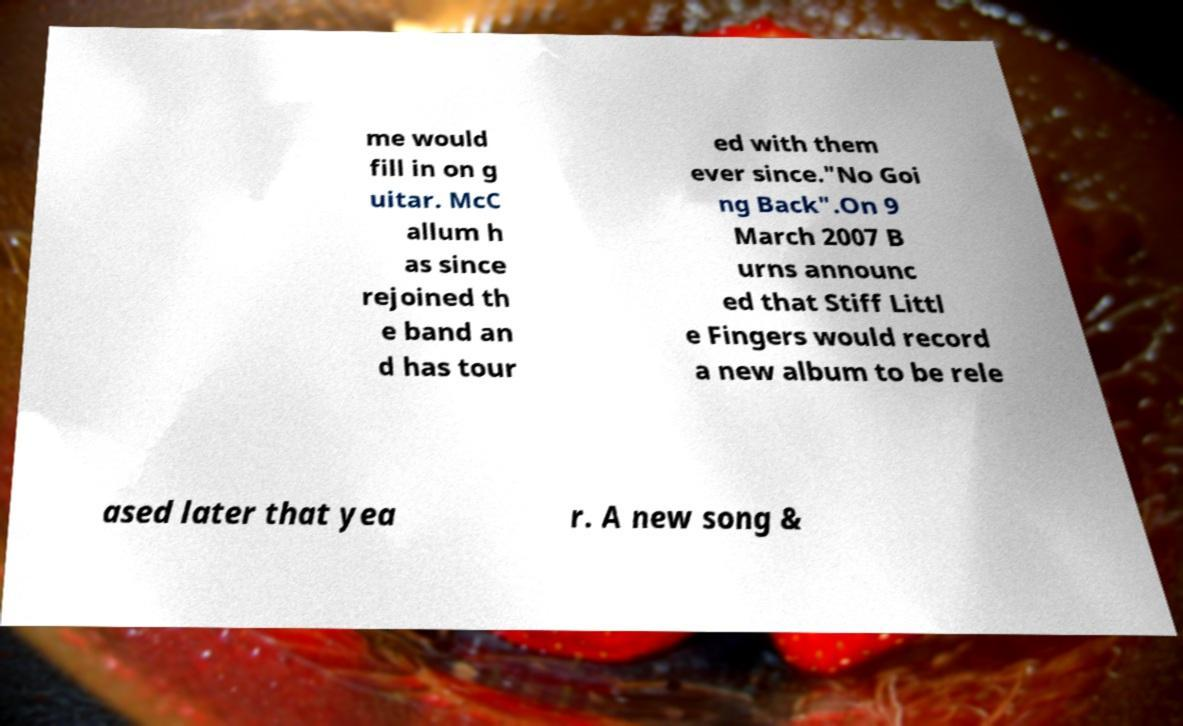Could you extract and type out the text from this image? me would fill in on g uitar. McC allum h as since rejoined th e band an d has tour ed with them ever since."No Goi ng Back".On 9 March 2007 B urns announc ed that Stiff Littl e Fingers would record a new album to be rele ased later that yea r. A new song & 